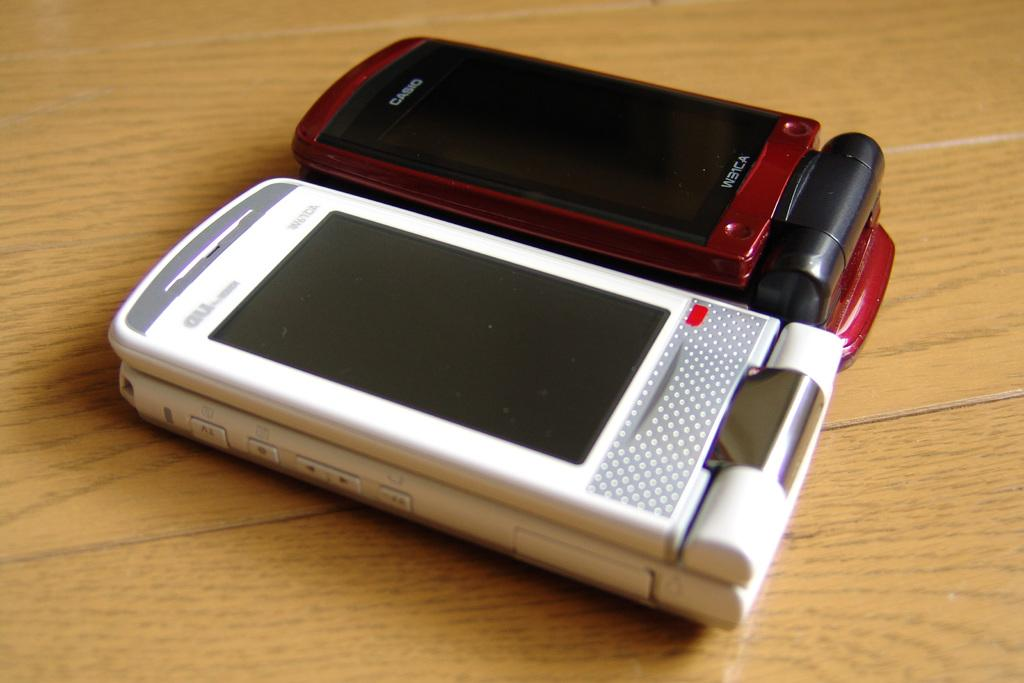<image>
Create a compact narrative representing the image presented. White cellphone next to a red Casio phone on a table. 